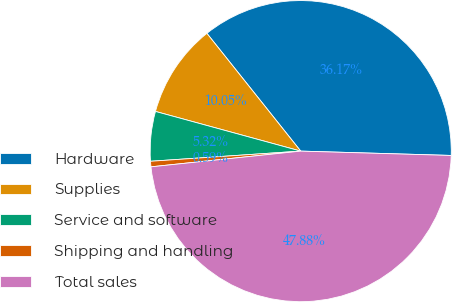Convert chart. <chart><loc_0><loc_0><loc_500><loc_500><pie_chart><fcel>Hardware<fcel>Supplies<fcel>Service and software<fcel>Shipping and handling<fcel>Total sales<nl><fcel>36.17%<fcel>10.05%<fcel>5.32%<fcel>0.59%<fcel>47.88%<nl></chart> 